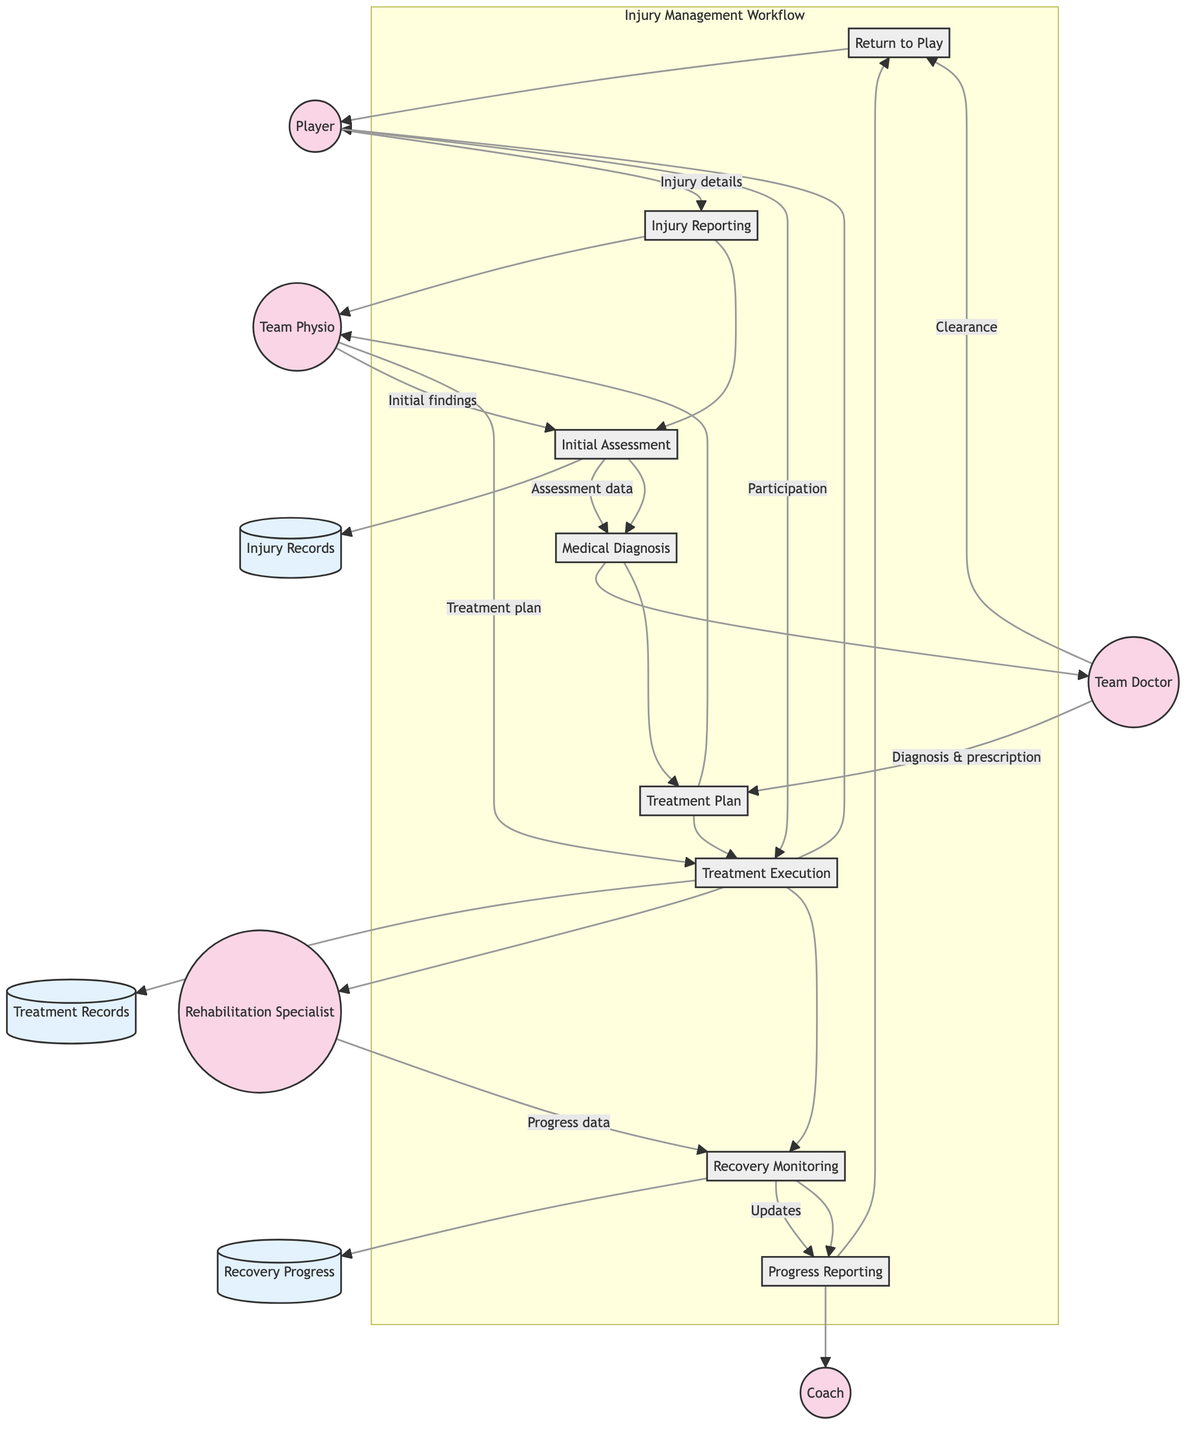What is the first process in the Injury Management Workflow? The first process is represented by the node that Player connects to, which is Injury Reporting. This shows that the Player initiates the workflow by reporting an injury.
Answer: Injury Reporting Who assesses the injury after the Player reports it? The next node after Injury Reporting is Initial Assessment, which is connected to Team Physio. This indicates that the Team Physio performs the assessment following the injury report.
Answer: Team Physio How many entities are involved in the workflow? By counting the nodes labeled as entities, we find there are five: Player, Team Physio, Team Doctor, Coach, and Rehabilitation Specialist.
Answer: Five What data does the Team Doctor send back to the Team Physio? After performing the Medical Diagnosis, the Team Doctor sends Diagnosis & prescription to the Team Physio, which is represented by the outgoing flow from the Team Doctor node.
Answer: Diagnosis & prescription What does the Rehabilitation Specialist provide to the Coach? The Rehabilitation Specialist monitors Recovery and sends updates to the Coach. This can be traced through the Recovery Monitoring process, which flows into Progress Reporting directed towards the Coach.
Answer: Updates Which process comes directly before Return to Play? To answer this, we look for the process that leads into Return to Play in the workflow. Progress Reporting is the process that precedes Return to Play, as it sends information to the Player regarding their recovery status.
Answer: Progress Reporting What type of records are stored in the Injury Records data store? The Injury Records data store holds detailed reports of player injuries, as indicated in the documentation of that data store.
Answer: Detailed reports of player injuries Which two roles are involved in creating a treatment plan? By observing the processes, Team Physio and Team Doctor participate in creating the Treatment Plan. Team Physio develops it based on the Medical Diagnosis provided by the Team Doctor.
Answer: Team Physio and Team Doctor What is the role of the Player during Treatment Execution? The Player participates in Treatment Execution by following the Treatment Plan. This step includes the Player's active involvement in their recovery under the guidance of the Team Physio and Rehabilitation Specialist.
Answer: Participation 